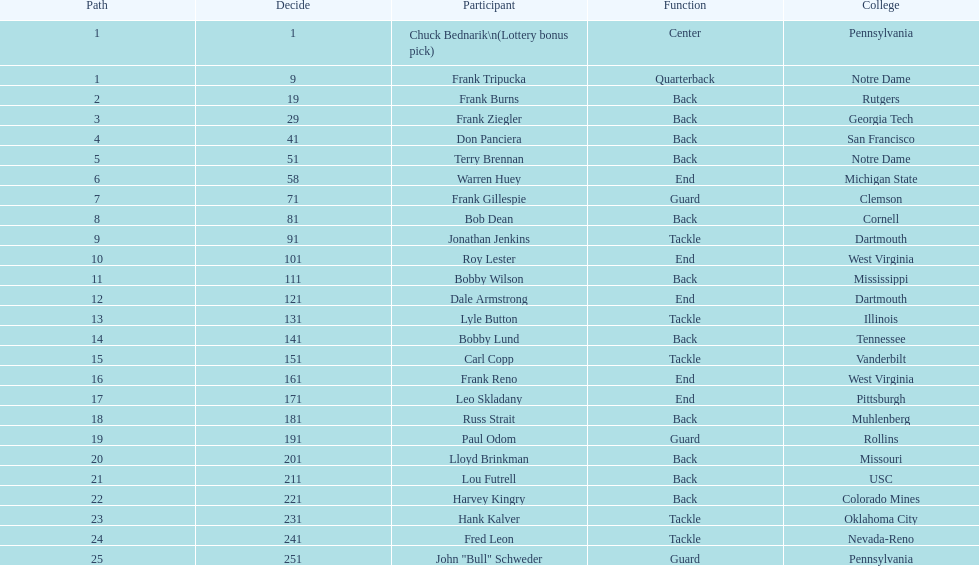Who was picked after frank burns? Frank Ziegler. 